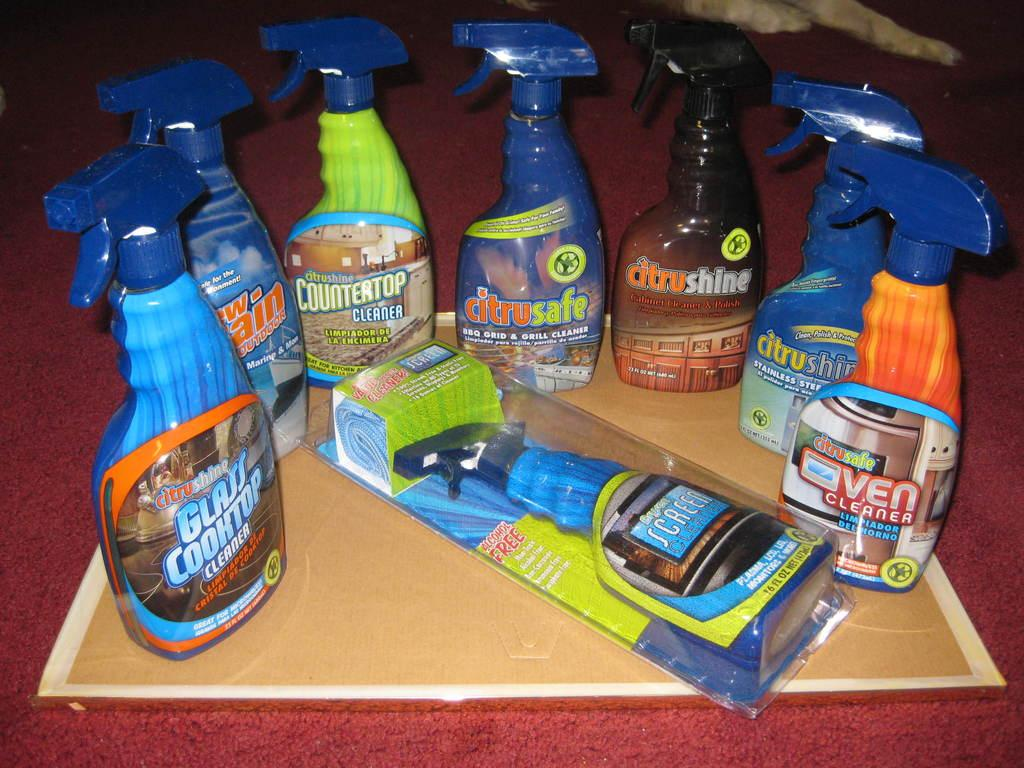Provide a one-sentence caption for the provided image. Glass Cook top spray on the left next to some other cleaning sprays. 